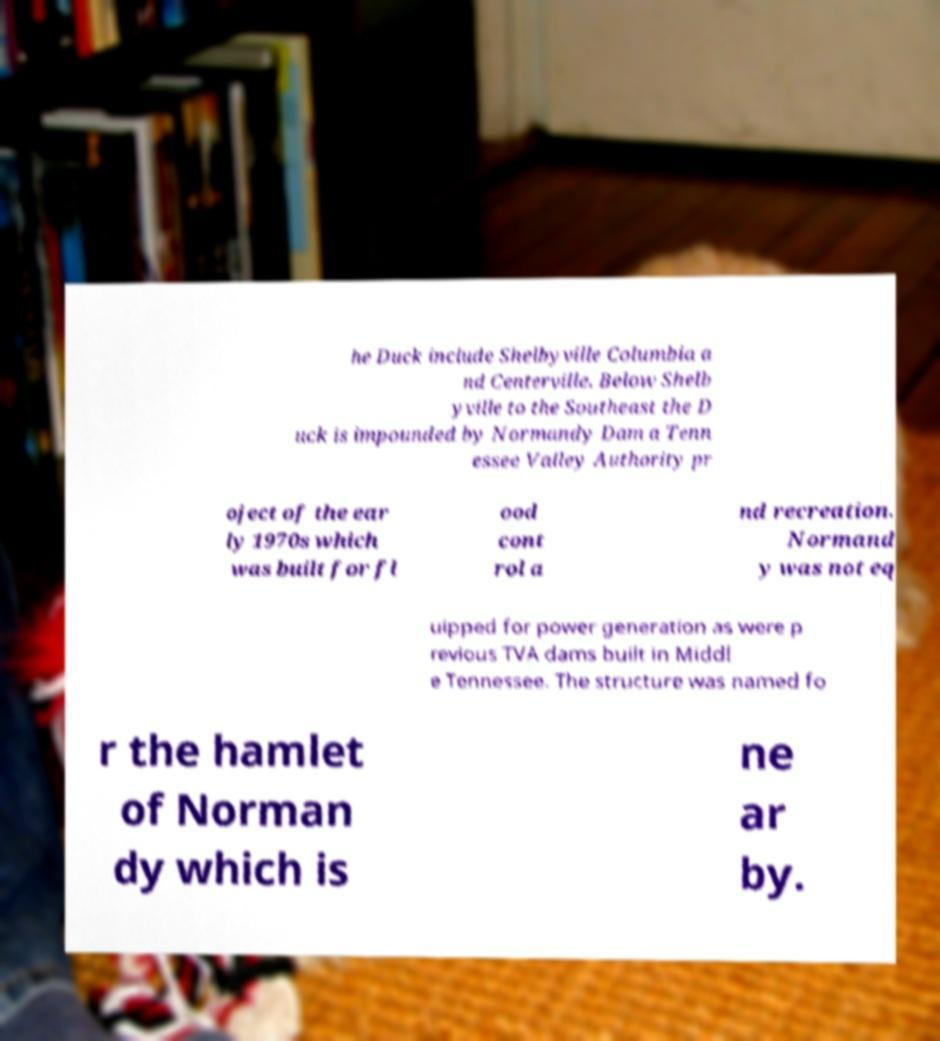What messages or text are displayed in this image? I need them in a readable, typed format. he Duck include Shelbyville Columbia a nd Centerville. Below Shelb yville to the Southeast the D uck is impounded by Normandy Dam a Tenn essee Valley Authority pr oject of the ear ly 1970s which was built for fl ood cont rol a nd recreation. Normand y was not eq uipped for power generation as were p revious TVA dams built in Middl e Tennessee. The structure was named fo r the hamlet of Norman dy which is ne ar by. 